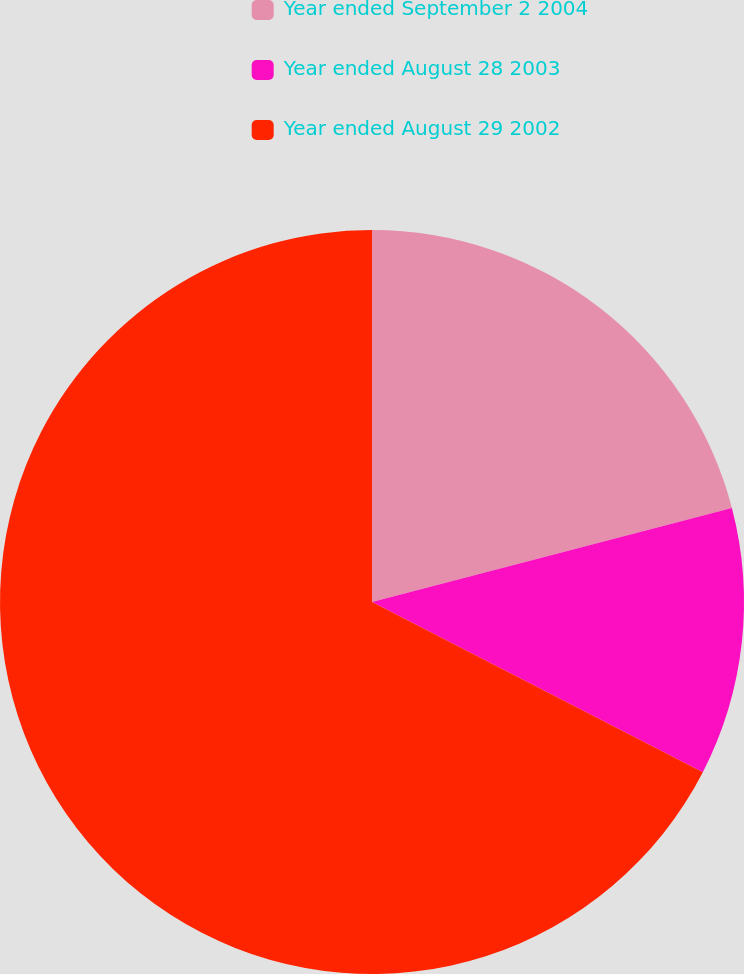Convert chart. <chart><loc_0><loc_0><loc_500><loc_500><pie_chart><fcel>Year ended September 2 2004<fcel>Year ended August 28 2003<fcel>Year ended August 29 2002<nl><fcel>20.93%<fcel>11.63%<fcel>67.44%<nl></chart> 